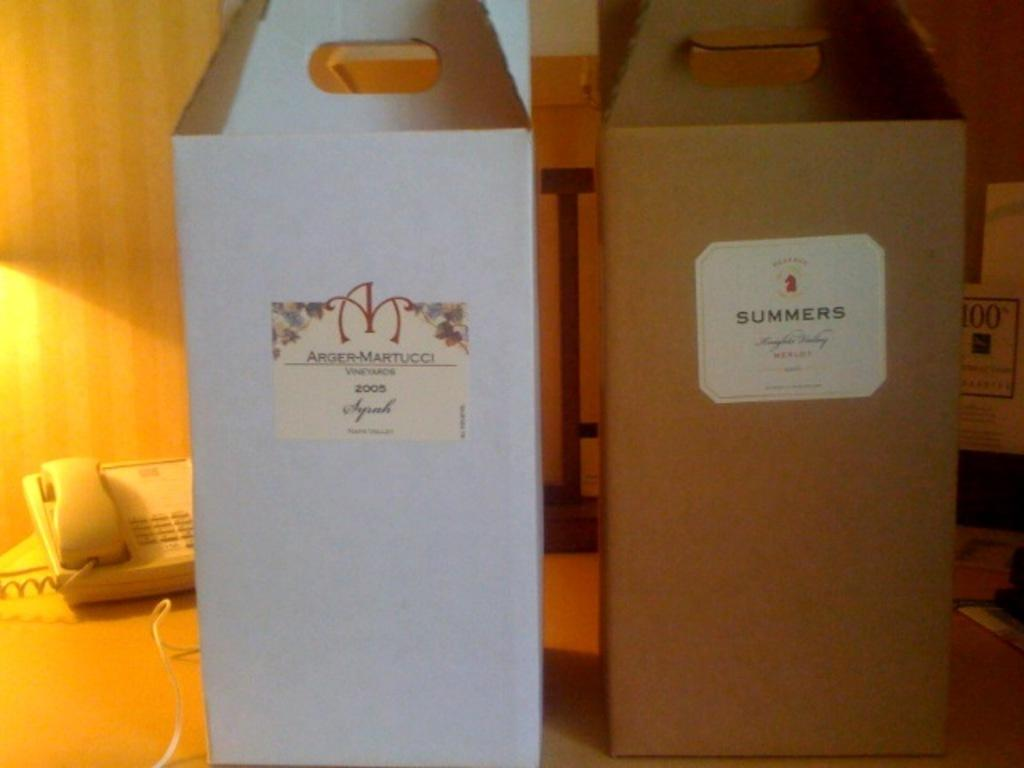<image>
Describe the image concisely. Boxes of merlot and syrah sit on a desk along with a telephone. 